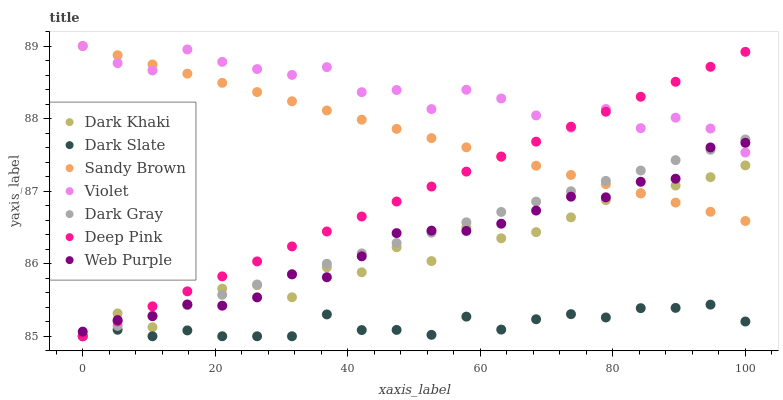Does Dark Slate have the minimum area under the curve?
Answer yes or no. Yes. Does Violet have the maximum area under the curve?
Answer yes or no. Yes. Does Deep Pink have the minimum area under the curve?
Answer yes or no. No. Does Deep Pink have the maximum area under the curve?
Answer yes or no. No. Is Sandy Brown the smoothest?
Answer yes or no. Yes. Is Dark Khaki the roughest?
Answer yes or no. Yes. Is Deep Pink the smoothest?
Answer yes or no. No. Is Deep Pink the roughest?
Answer yes or no. No. Does Dark Gray have the lowest value?
Answer yes or no. Yes. Does Dark Khaki have the lowest value?
Answer yes or no. No. Does Sandy Brown have the highest value?
Answer yes or no. Yes. Does Deep Pink have the highest value?
Answer yes or no. No. Is Dark Slate less than Violet?
Answer yes or no. Yes. Is Violet greater than Dark Slate?
Answer yes or no. Yes. Does Web Purple intersect Dark Khaki?
Answer yes or no. Yes. Is Web Purple less than Dark Khaki?
Answer yes or no. No. Is Web Purple greater than Dark Khaki?
Answer yes or no. No. Does Dark Slate intersect Violet?
Answer yes or no. No. 